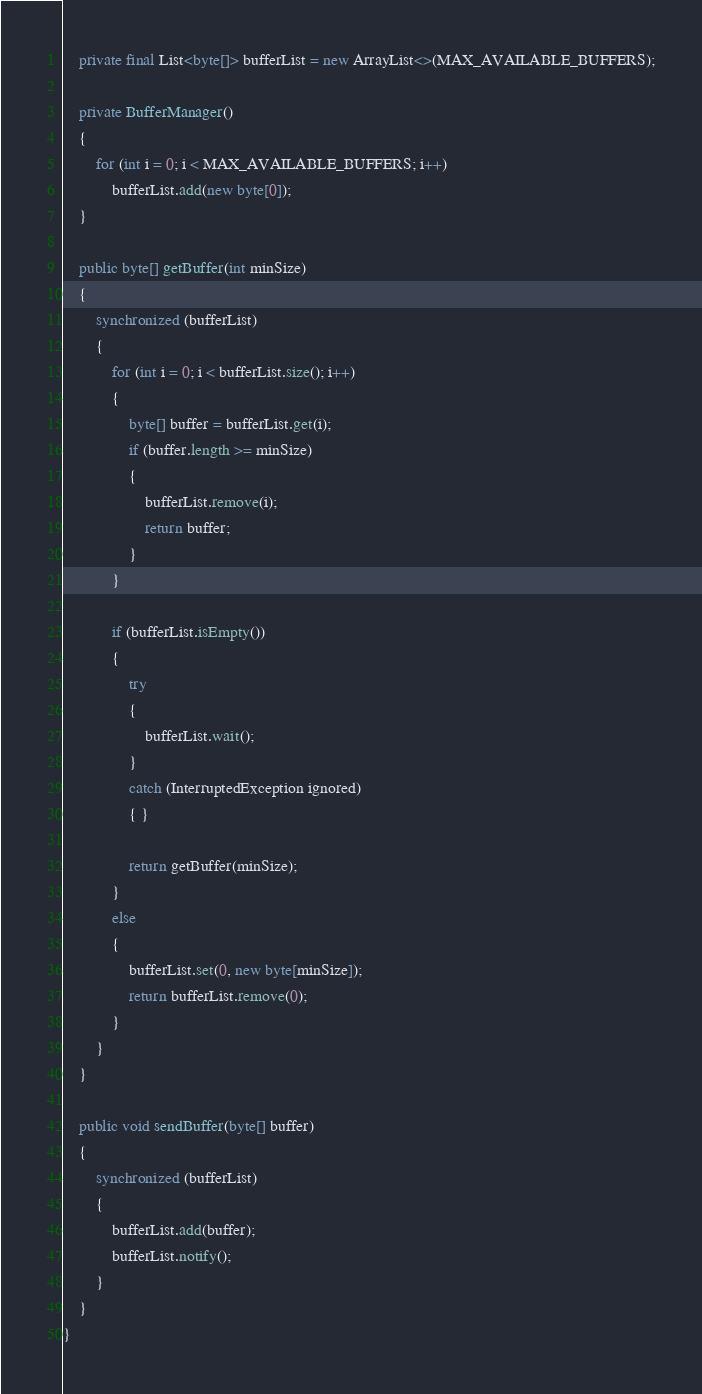Convert code to text. <code><loc_0><loc_0><loc_500><loc_500><_Java_>    private final List<byte[]> bufferList = new ArrayList<>(MAX_AVAILABLE_BUFFERS);

    private BufferManager()
    {
        for (int i = 0; i < MAX_AVAILABLE_BUFFERS; i++)
            bufferList.add(new byte[0]);
    }

    public byte[] getBuffer(int minSize)
    {
        synchronized (bufferList)
        {
            for (int i = 0; i < bufferList.size(); i++)
            {
                byte[] buffer = bufferList.get(i);
                if (buffer.length >= minSize)
                {
                    bufferList.remove(i);
                    return buffer;
                }
            }

            if (bufferList.isEmpty())
            {
                try
                {
                    bufferList.wait();
                }
                catch (InterruptedException ignored)
                { }

                return getBuffer(minSize);
            }
            else
            {
                bufferList.set(0, new byte[minSize]);
                return bufferList.remove(0);
            }
        }
    }

    public void sendBuffer(byte[] buffer)
    {
        synchronized (bufferList)
        {
            bufferList.add(buffer);
            bufferList.notify();
        }
    }
}
</code> 